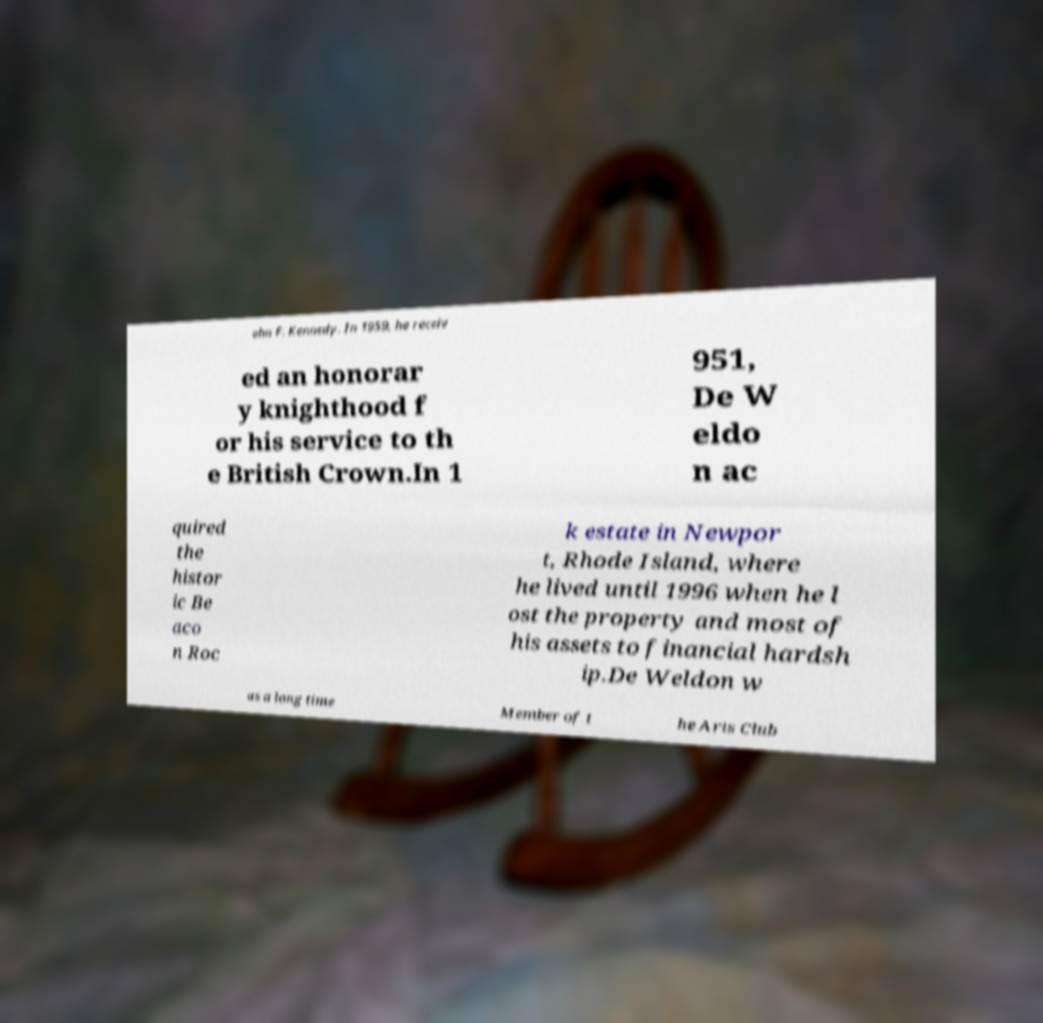For documentation purposes, I need the text within this image transcribed. Could you provide that? ohn F. Kennedy. In 1959, he receiv ed an honorar y knighthood f or his service to th e British Crown.In 1 951, De W eldo n ac quired the histor ic Be aco n Roc k estate in Newpor t, Rhode Island, where he lived until 1996 when he l ost the property and most of his assets to financial hardsh ip.De Weldon w as a long time Member of t he Arts Club 